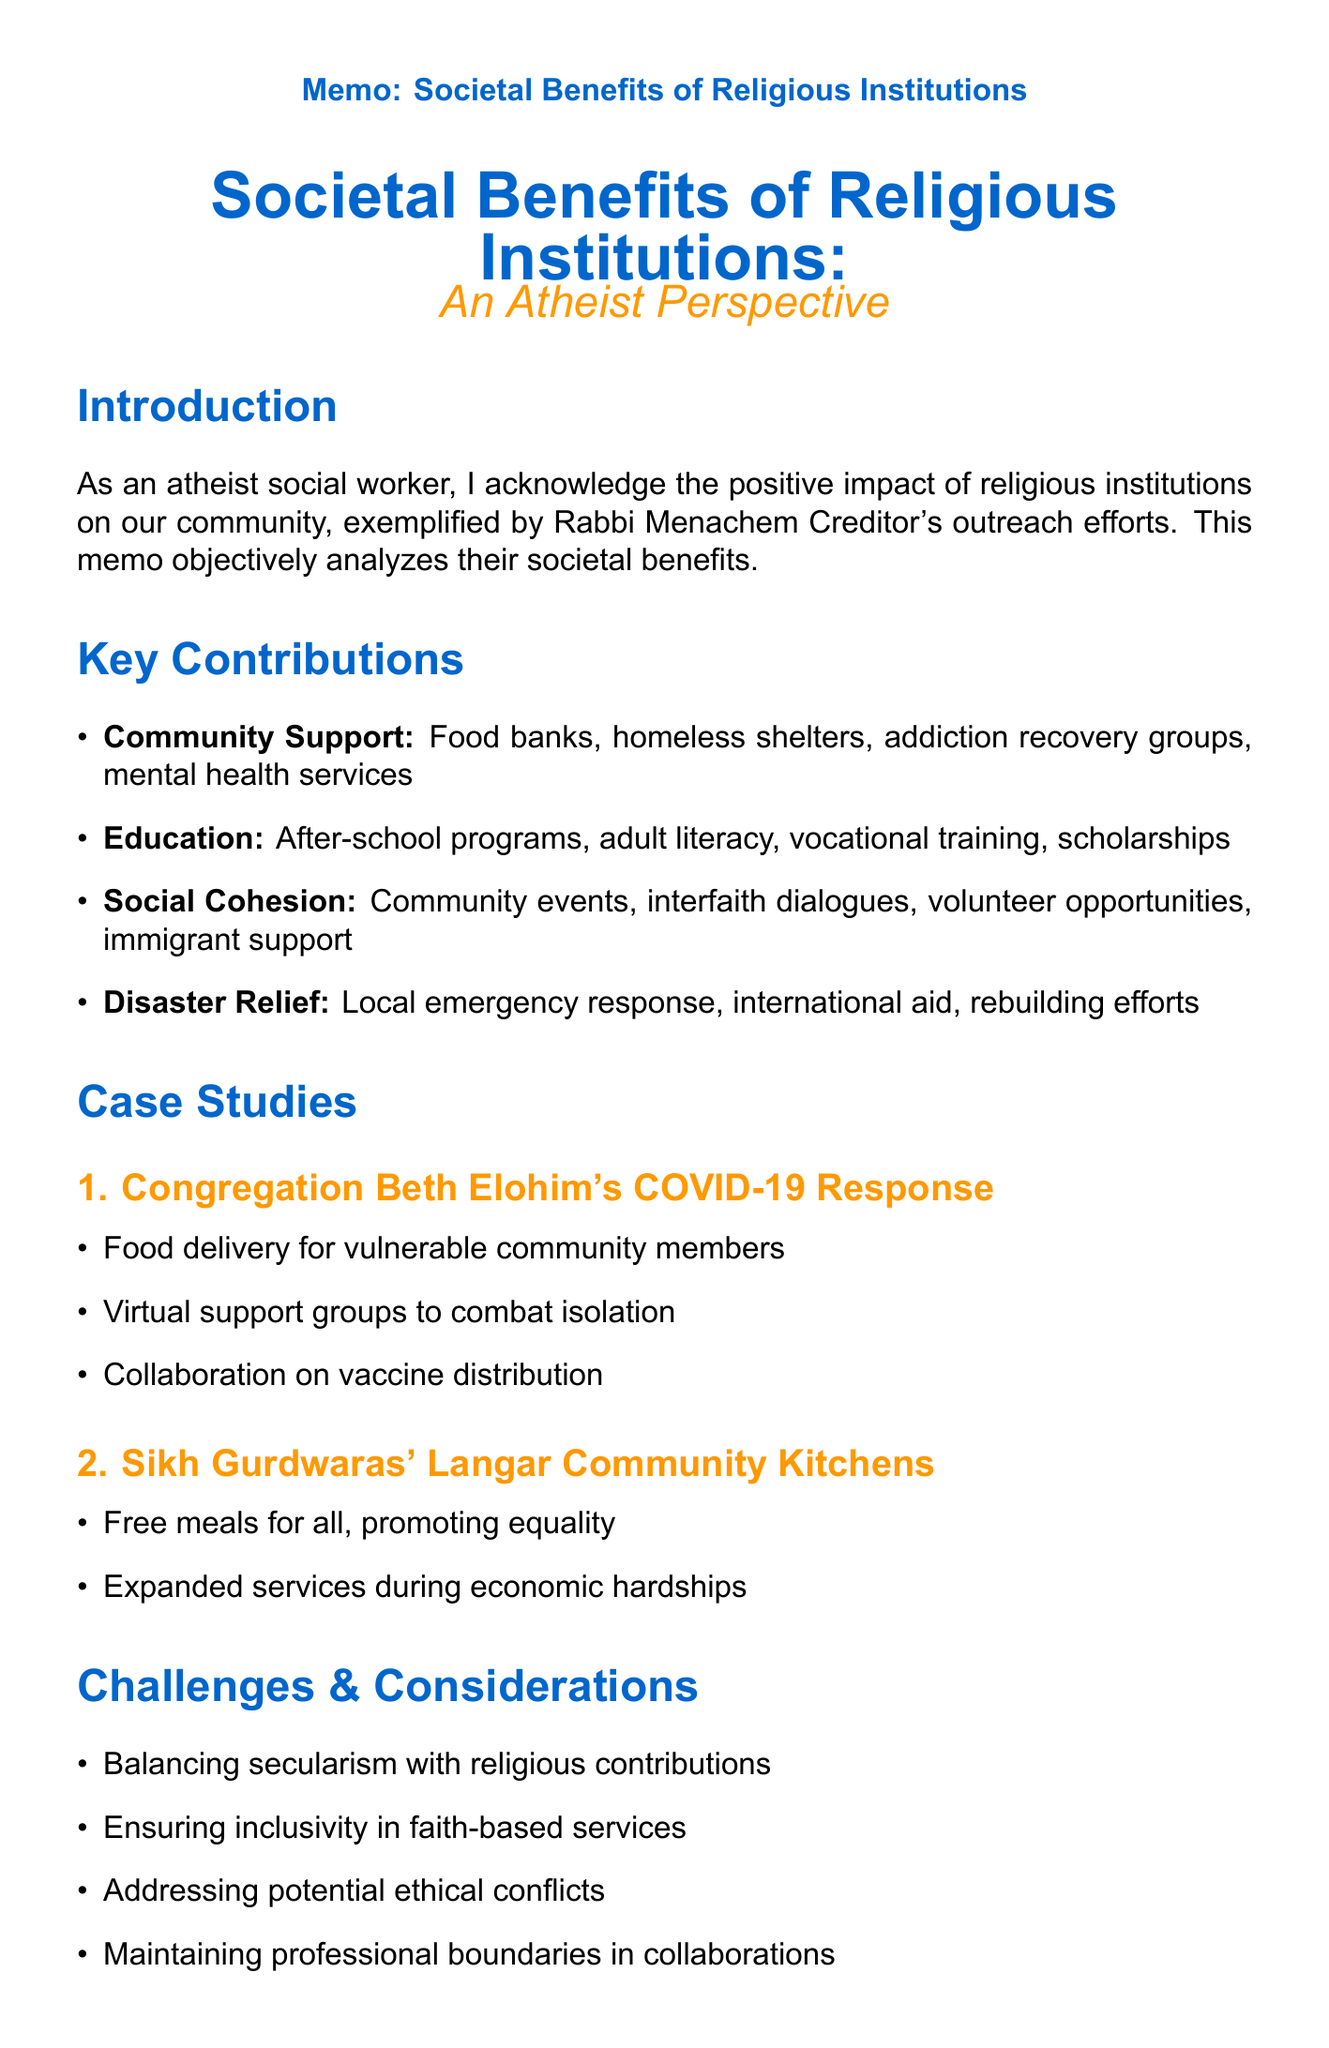What is the title of the memo? The title of the memo is stated at the beginning, indicating the main topic.
Answer: Societal Benefits of Religious Institutions: An Atheist Perspective Who is mentioned as a local example in the introduction? The introduction highlights a specific individual who represents local community outreach efforts.
Answer: Rabbi Menachem Creditor Name a type of community support mentioned in the document. The document lists various types of support; one is specifically food assistance.
Answer: Food banks What is one example of an educational initiative? The main sections provide examples of programs aimed at education; one such initiative is highlighted.
Answer: After-school programs for at-risk youth What is one challenge regarding faith-based services? The challenges section discusses specific issues that might arise in collaboration with religious institutions.
Answer: Ensuring inclusivity and non-discrimination in faith-based services How many case studies are presented in the memo? The case studies section counts how many specific examples of religious institutions providing community support are listed.
Answer: 2 What is a key takeaway mentioned in the conclusion? The conclusion summarizes the main points, focusing on the implications for social work.
Answer: Religious institutions offer valuable resources and support networks 